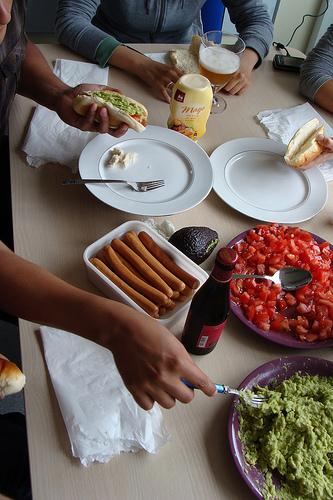Identify the colors and objects of the two different plates. The first plate is purple with guacamole and tomatoes, and the second plate is white with hot dogs. Describe the overall sentiment and atmosphere of the image. A casual dining scene with enjoyable food like hot dogs, guacamole, and avocado, accompanied by a refreshing bottled beer. Give a brief description of what's in the image involving the avocado. There is an avocado that has been cut into on the table, and a person is enjoying hot dog and guacamole with it. How many different plates are there on the table and what do they contain? Two different plates: a purple one with guacamole and tomatoes, and a white one with hot dogs. Explain what is happening with the phone in the image. A phone is on the table and has a black cable connected to it. Explain what the person is doing with the fork and hot dog. A person is holding a fork with guacamole on it and another person holding a hot dog with guacamole on it. What kinds of foods can be seen in the image? Hot dogs, guacamole, cut avocado, and small pieces of tomato. Describe the type of table and its main contents. A wooden dining table with various plates containing hot dogs, guacamole, tomatoes, and a cut avocado. What are the main objects on the dining table? An avocado, a round purple plate of guacamole, a round white plate, hot dogs in a dish, tomatoes on a plate, a bottle of beer, and a phone. What kind of beverage can be seen on the table? A bottled beer with a red label. Where is the red handbag on the table? There is a bag mentioned in the image, but its color isn't specified; thus, it is misleading to ask about a red handbag specifically. Which person is holding a fork with an apple on it? There is a hand holding a fork with guacamole on it, but no hand holding a fork with an apple on it. Is there a sliced cucumber on the image? There is no cucumber mentioned in the image. There is an avocado that has been cut into, but it is not the same as a cucumber. Can you point out the orange hotdog bun in the image? There is an empty hotdog bun mentioned but its color is not specified. It's misleading to assume it is orange. Is the spoon on the table pink? There is a grey spoon in the image, but there is no pink spoon. Can you find a blue plate with tomatoes on it? There are purple and white plates with tomatoes on them, but no blue plate is mentioned in the image. 